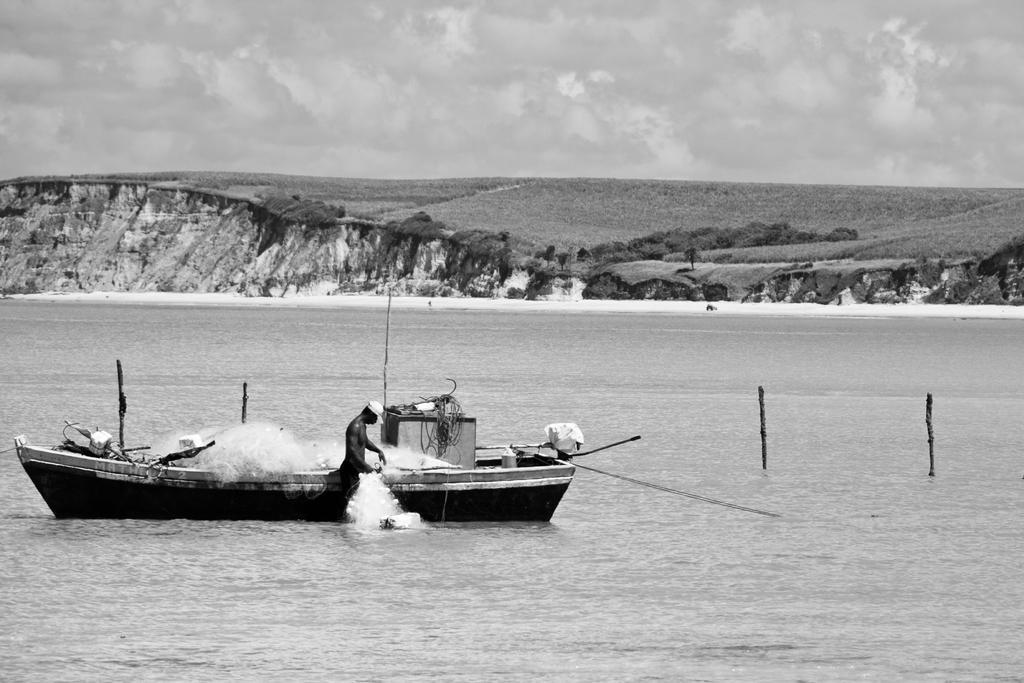Please provide a concise description of this image. It is a black and white image, there is a water surface and there is a boat floating on the water surface, there is a person beside the boat, he is doing some work and in the background there are small mountains. 